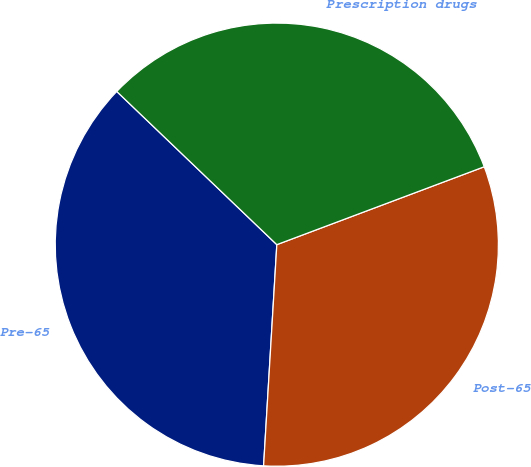<chart> <loc_0><loc_0><loc_500><loc_500><pie_chart><fcel>Pre-65<fcel>Post-65<fcel>Prescription drugs<nl><fcel>36.2%<fcel>31.67%<fcel>32.13%<nl></chart> 